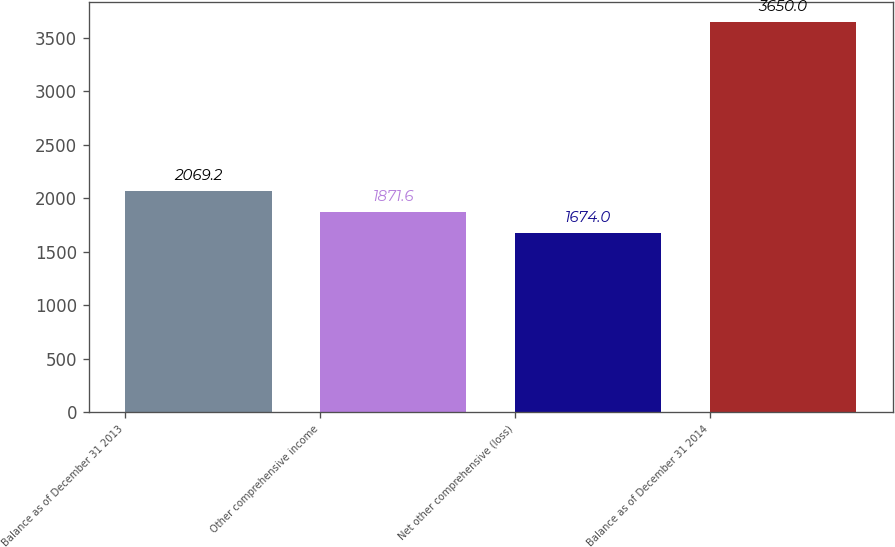Convert chart to OTSL. <chart><loc_0><loc_0><loc_500><loc_500><bar_chart><fcel>Balance as of December 31 2013<fcel>Other comprehensive income<fcel>Net other comprehensive (loss)<fcel>Balance as of December 31 2014<nl><fcel>2069.2<fcel>1871.6<fcel>1674<fcel>3650<nl></chart> 